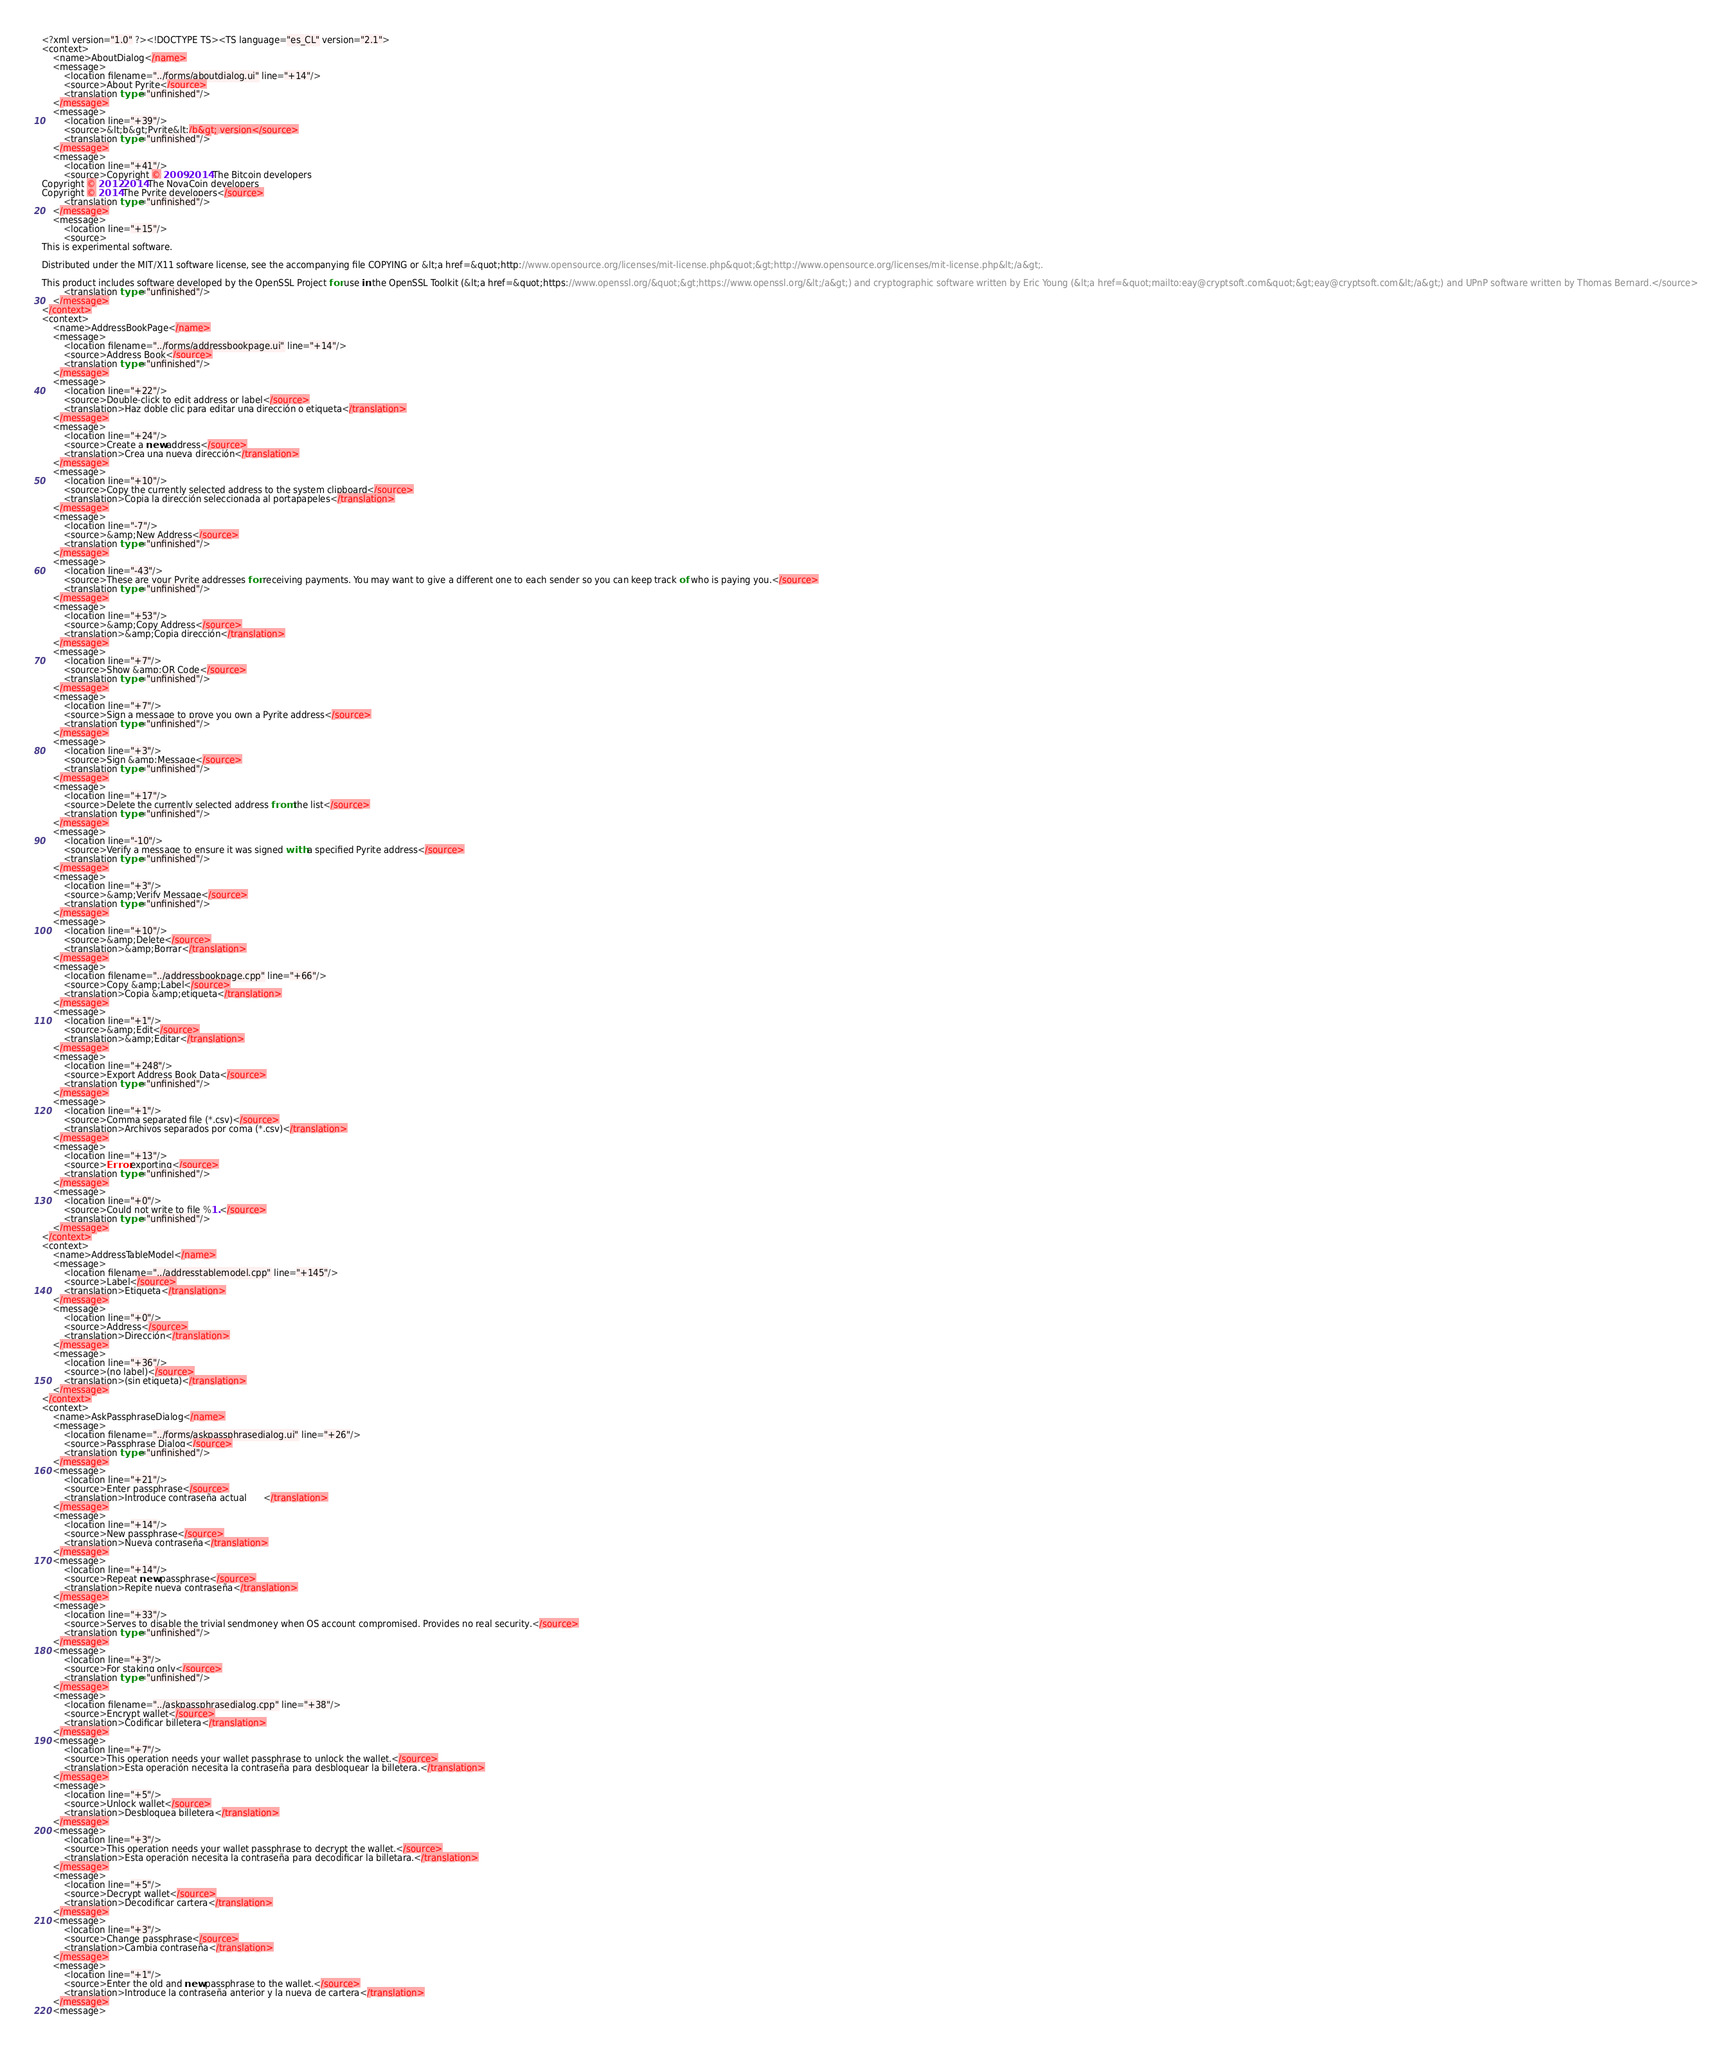<code> <loc_0><loc_0><loc_500><loc_500><_TypeScript_><?xml version="1.0" ?><!DOCTYPE TS><TS language="es_CL" version="2.1">
<context>
    <name>AboutDialog</name>
    <message>
        <location filename="../forms/aboutdialog.ui" line="+14"/>
        <source>About Pyrite</source>
        <translation type="unfinished"/>
    </message>
    <message>
        <location line="+39"/>
        <source>&lt;b&gt;Pyrite&lt;/b&gt; version</source>
        <translation type="unfinished"/>
    </message>
    <message>
        <location line="+41"/>
        <source>Copyright © 2009-2014 The Bitcoin developers
Copyright © 2012-2014 The NovaCoin developers
Copyright © 2014 The Pyrite developers</source>
        <translation type="unfinished"/>
    </message>
    <message>
        <location line="+15"/>
        <source>
This is experimental software.

Distributed under the MIT/X11 software license, see the accompanying file COPYING or &lt;a href=&quot;http://www.opensource.org/licenses/mit-license.php&quot;&gt;http://www.opensource.org/licenses/mit-license.php&lt;/a&gt;.

This product includes software developed by the OpenSSL Project for use in the OpenSSL Toolkit (&lt;a href=&quot;https://www.openssl.org/&quot;&gt;https://www.openssl.org/&lt;/a&gt;) and cryptographic software written by Eric Young (&lt;a href=&quot;mailto:eay@cryptsoft.com&quot;&gt;eay@cryptsoft.com&lt;/a&gt;) and UPnP software written by Thomas Bernard.</source>
        <translation type="unfinished"/>
    </message>
</context>
<context>
    <name>AddressBookPage</name>
    <message>
        <location filename="../forms/addressbookpage.ui" line="+14"/>
        <source>Address Book</source>
        <translation type="unfinished"/>
    </message>
    <message>
        <location line="+22"/>
        <source>Double-click to edit address or label</source>
        <translation>Haz doble clic para editar una dirección o etiqueta</translation>
    </message>
    <message>
        <location line="+24"/>
        <source>Create a new address</source>
        <translation>Crea una nueva dirección</translation>
    </message>
    <message>
        <location line="+10"/>
        <source>Copy the currently selected address to the system clipboard</source>
        <translation>Copia la dirección seleccionada al portapapeles</translation>
    </message>
    <message>
        <location line="-7"/>
        <source>&amp;New Address</source>
        <translation type="unfinished"/>
    </message>
    <message>
        <location line="-43"/>
        <source>These are your Pyrite addresses for receiving payments. You may want to give a different one to each sender so you can keep track of who is paying you.</source>
        <translation type="unfinished"/>
    </message>
    <message>
        <location line="+53"/>
        <source>&amp;Copy Address</source>
        <translation>&amp;Copia dirección</translation>
    </message>
    <message>
        <location line="+7"/>
        <source>Show &amp;QR Code</source>
        <translation type="unfinished"/>
    </message>
    <message>
        <location line="+7"/>
        <source>Sign a message to prove you own a Pyrite address</source>
        <translation type="unfinished"/>
    </message>
    <message>
        <location line="+3"/>
        <source>Sign &amp;Message</source>
        <translation type="unfinished"/>
    </message>
    <message>
        <location line="+17"/>
        <source>Delete the currently selected address from the list</source>
        <translation type="unfinished"/>
    </message>
    <message>
        <location line="-10"/>
        <source>Verify a message to ensure it was signed with a specified Pyrite address</source>
        <translation type="unfinished"/>
    </message>
    <message>
        <location line="+3"/>
        <source>&amp;Verify Message</source>
        <translation type="unfinished"/>
    </message>
    <message>
        <location line="+10"/>
        <source>&amp;Delete</source>
        <translation>&amp;Borrar</translation>
    </message>
    <message>
        <location filename="../addressbookpage.cpp" line="+66"/>
        <source>Copy &amp;Label</source>
        <translation>Copia &amp;etiqueta</translation>
    </message>
    <message>
        <location line="+1"/>
        <source>&amp;Edit</source>
        <translation>&amp;Editar</translation>
    </message>
    <message>
        <location line="+248"/>
        <source>Export Address Book Data</source>
        <translation type="unfinished"/>
    </message>
    <message>
        <location line="+1"/>
        <source>Comma separated file (*.csv)</source>
        <translation>Archivos separados por coma (*.csv)</translation>
    </message>
    <message>
        <location line="+13"/>
        <source>Error exporting</source>
        <translation type="unfinished"/>
    </message>
    <message>
        <location line="+0"/>
        <source>Could not write to file %1.</source>
        <translation type="unfinished"/>
    </message>
</context>
<context>
    <name>AddressTableModel</name>
    <message>
        <location filename="../addresstablemodel.cpp" line="+145"/>
        <source>Label</source>
        <translation>Etiqueta</translation>
    </message>
    <message>
        <location line="+0"/>
        <source>Address</source>
        <translation>Dirección</translation>
    </message>
    <message>
        <location line="+36"/>
        <source>(no label)</source>
        <translation>(sin etiqueta)</translation>
    </message>
</context>
<context>
    <name>AskPassphraseDialog</name>
    <message>
        <location filename="../forms/askpassphrasedialog.ui" line="+26"/>
        <source>Passphrase Dialog</source>
        <translation type="unfinished"/>
    </message>
    <message>
        <location line="+21"/>
        <source>Enter passphrase</source>
        <translation>Introduce contraseña actual      </translation>
    </message>
    <message>
        <location line="+14"/>
        <source>New passphrase</source>
        <translation>Nueva contraseña</translation>
    </message>
    <message>
        <location line="+14"/>
        <source>Repeat new passphrase</source>
        <translation>Repite nueva contraseña</translation>
    </message>
    <message>
        <location line="+33"/>
        <source>Serves to disable the trivial sendmoney when OS account compromised. Provides no real security.</source>
        <translation type="unfinished"/>
    </message>
    <message>
        <location line="+3"/>
        <source>For staking only</source>
        <translation type="unfinished"/>
    </message>
    <message>
        <location filename="../askpassphrasedialog.cpp" line="+38"/>
        <source>Encrypt wallet</source>
        <translation>Codificar billetera</translation>
    </message>
    <message>
        <location line="+7"/>
        <source>This operation needs your wallet passphrase to unlock the wallet.</source>
        <translation>Esta operación necesita la contraseña para desbloquear la billetera.</translation>
    </message>
    <message>
        <location line="+5"/>
        <source>Unlock wallet</source>
        <translation>Desbloquea billetera</translation>
    </message>
    <message>
        <location line="+3"/>
        <source>This operation needs your wallet passphrase to decrypt the wallet.</source>
        <translation>Esta operación necesita la contraseña para decodificar la billetara.</translation>
    </message>
    <message>
        <location line="+5"/>
        <source>Decrypt wallet</source>
        <translation>Decodificar cartera</translation>
    </message>
    <message>
        <location line="+3"/>
        <source>Change passphrase</source>
        <translation>Cambia contraseña</translation>
    </message>
    <message>
        <location line="+1"/>
        <source>Enter the old and new passphrase to the wallet.</source>
        <translation>Introduce la contraseña anterior y la nueva de cartera</translation>
    </message>
    <message></code> 